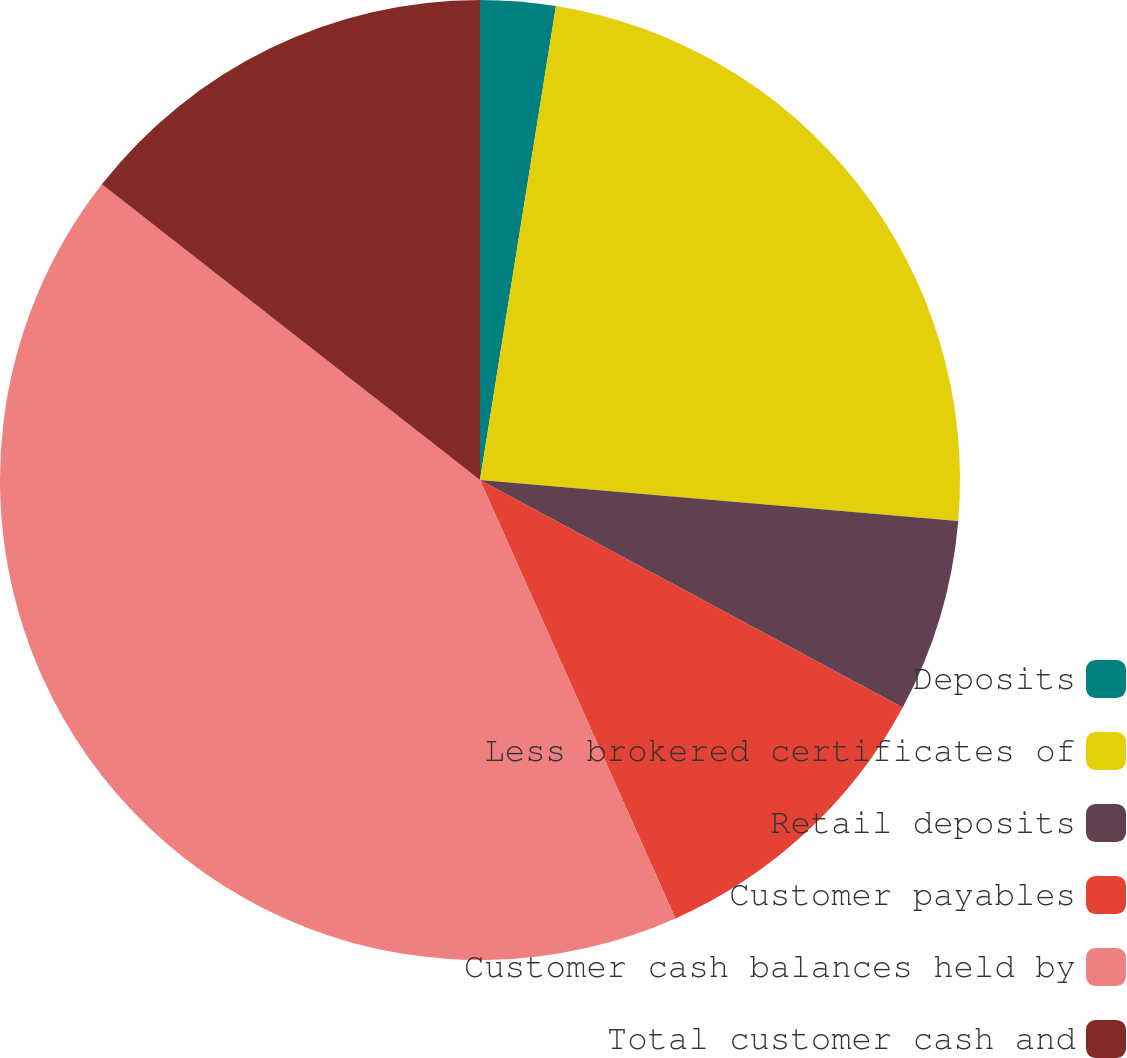<chart> <loc_0><loc_0><loc_500><loc_500><pie_chart><fcel>Deposits<fcel>Less brokered certificates of<fcel>Retail deposits<fcel>Customer payables<fcel>Customer cash balances held by<fcel>Total customer cash and<nl><fcel>2.53%<fcel>23.83%<fcel>6.5%<fcel>10.47%<fcel>42.24%<fcel>14.44%<nl></chart> 